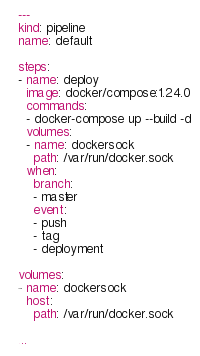Convert code to text. <code><loc_0><loc_0><loc_500><loc_500><_YAML_>---
kind: pipeline
name: default

steps:
- name: deploy
  image: docker/compose:1.24.0
  commands:
  - docker-compose up --build -d
  volumes:
  - name: dockersock
    path: /var/run/docker.sock
  when:
    branch:
    - master
    event:
    - push
    - tag
    - deployment

volumes:
- name: dockersock
  host:
    path: /var/run/docker.sock

...
</code> 